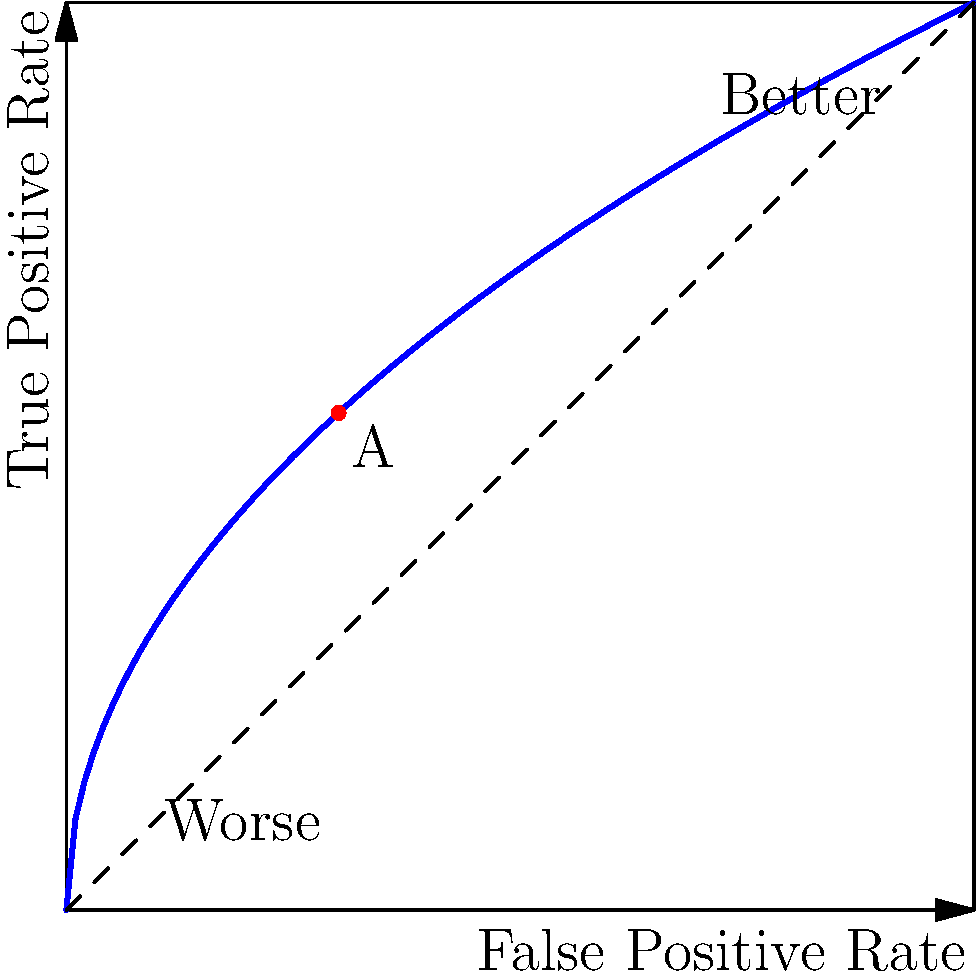As a project director evaluating a machine learning model for predicting project success, you're presented with the ROC curve above. What does point A (0.3, 0.55) on the curve represent in terms of the model's performance, and how would you interpret this for strategic planning purposes? To interpret the ROC curve and point A for strategic planning purposes, let's follow these steps:

1. Understanding the ROC curve:
   - The x-axis represents the False Positive Rate (FPR)
   - The y-axis represents the True Positive Rate (TPR)
   - The curve shows the trade-off between TPR and FPR at various classification thresholds

2. Interpreting point A (0.3, 0.55):
   - FPR = 0.3 (x-coordinate)
   - TPR = 0.55 (y-coordinate)

3. Calculating specificity:
   Specificity = 1 - FPR = 1 - 0.3 = 0.7

4. Interpreting the values:
   - TPR (0.55): The model correctly identifies 55% of successful projects
   - Specificity (0.7): The model correctly identifies 70% of unsuccessful projects

5. Assessing model performance:
   - The point is above the diagonal line, indicating better-than-random performance
   - However, it's not very close to the top-left corner, suggesting moderate performance

6. Strategic planning implications:
   - The model has a balanced performance between identifying successful and unsuccessful projects
   - It can be useful for initial project screening but shouldn't be the sole decision-making factor
   - There's room for improvement in the model's predictive power

7. Risk management considerations:
   - False positives (30%) might lead to resource allocation to potentially unsuccessful projects
   - False negatives (45%) could result in missed opportunities for successful projects

8. Potential actions:
   - Use the model as a supplementary tool in the decision-making process
   - Consider adjusting the classification threshold based on risk tolerance
   - Investigate additional features or data sources to improve model performance

In summary, point A represents a moderate performance level with a balanced trade-off between identifying successful and unsuccessful projects, which can be useful for initial project screening but should be combined with other factors in strategic planning and risk management decisions.
Answer: Point A (0.3, 0.55) represents a 55% true positive rate and 70% specificity, indicating moderate model performance useful for initial project screening but requiring additional considerations for strategic planning and risk management decisions. 